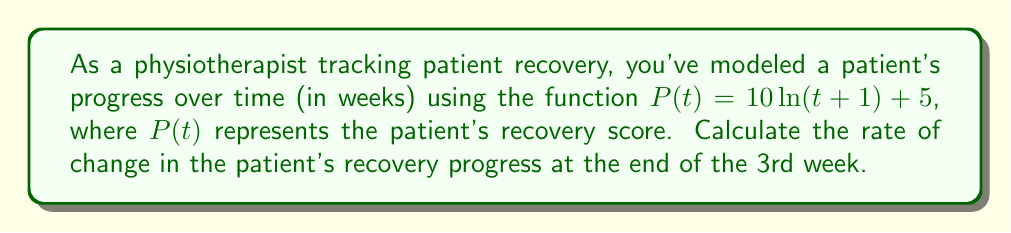Teach me how to tackle this problem. To find the rate of change in the patient's recovery progress at a specific time, we need to calculate the derivative of the given function and evaluate it at the desired point.

1. The given function is $P(t) = 10\ln(t+1) + 5$

2. To find the derivative, we use the chain rule:
   $$\frac{d}{dt}[10\ln(t+1)] = 10 \cdot \frac{1}{t+1} \cdot \frac{d}{dt}(t+1) = \frac{10}{t+1}$$
   $$\frac{d}{dt}[5] = 0$$

3. Combining these results, we get the derivative:
   $$P'(t) = \frac{10}{t+1}$$

4. To find the rate of change at the end of the 3rd week, we evaluate $P'(t)$ at $t = 3$:
   $$P'(3) = \frac{10}{3+1} = \frac{10}{4} = 2.5$$

Therefore, the rate of change in the patient's recovery progress at the end of the 3rd week is 2.5 units per week.
Answer: 2.5 units/week 